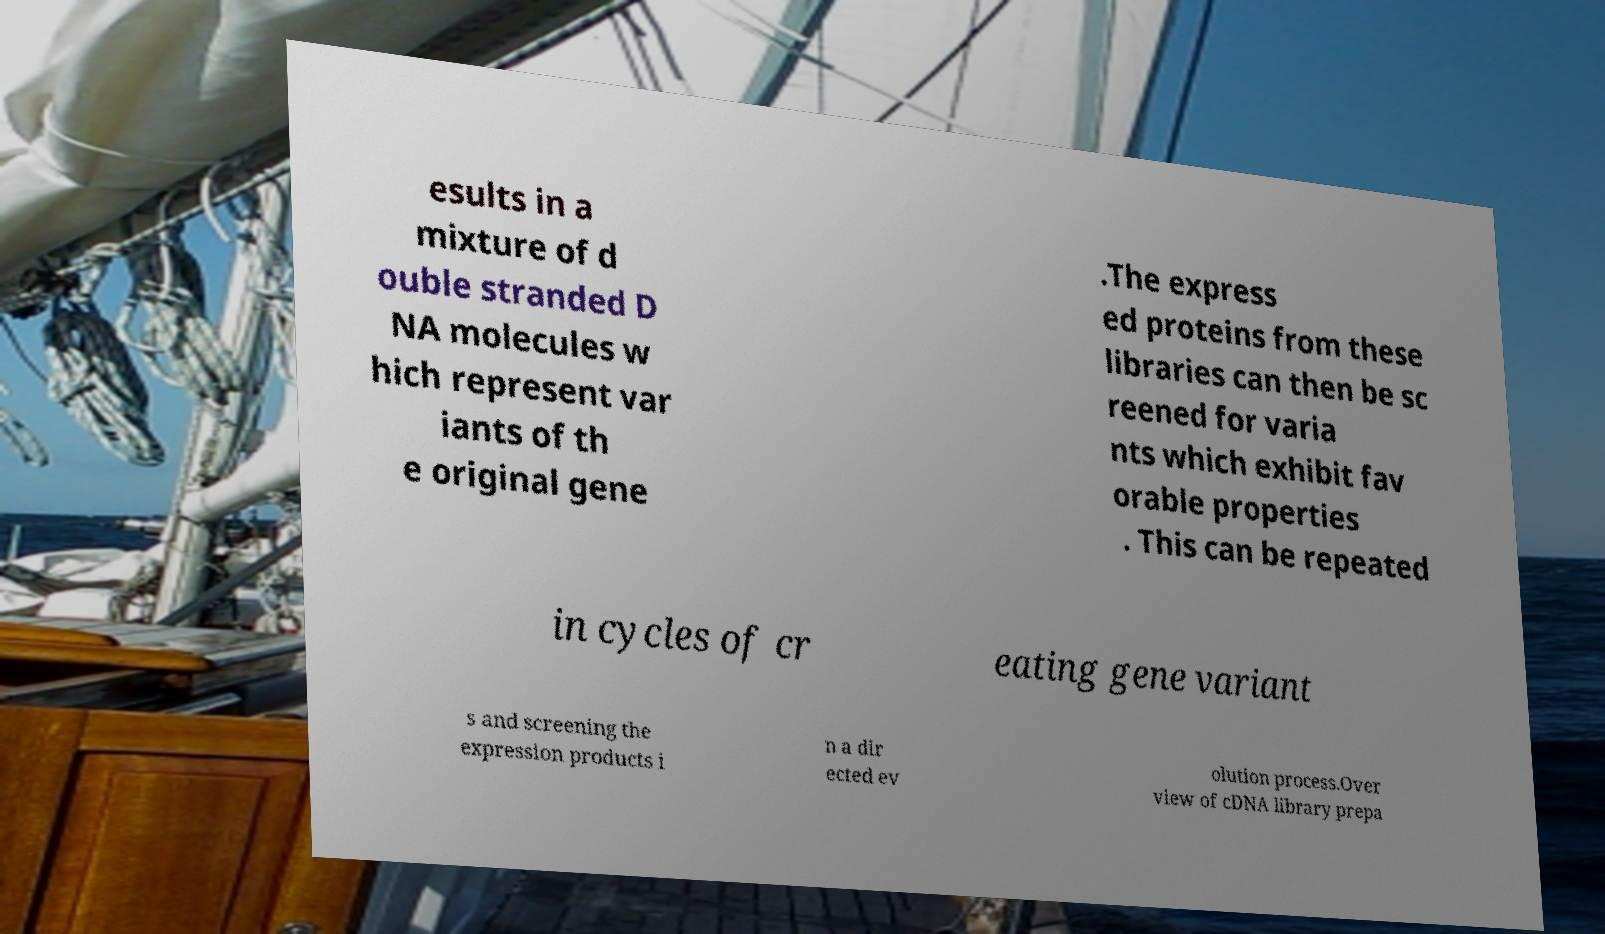I need the written content from this picture converted into text. Can you do that? esults in a mixture of d ouble stranded D NA molecules w hich represent var iants of th e original gene .The express ed proteins from these libraries can then be sc reened for varia nts which exhibit fav orable properties . This can be repeated in cycles of cr eating gene variant s and screening the expression products i n a dir ected ev olution process.Over view of cDNA library prepa 